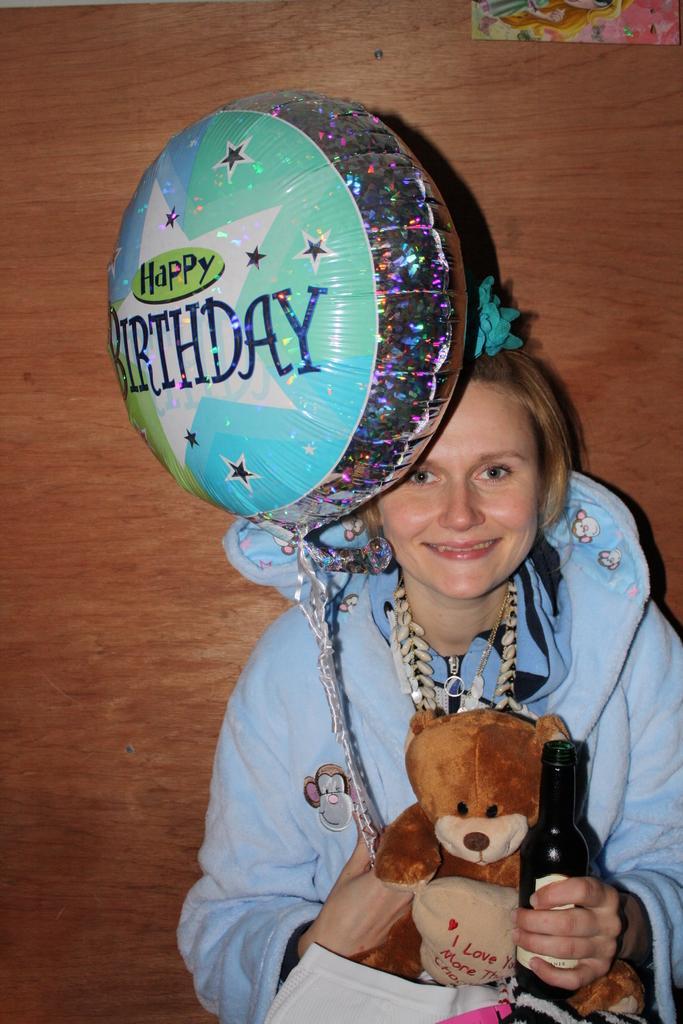In one or two sentences, can you explain what this image depicts? In this picture, woman in blue jacket is holding teddy bear in one of her hand and on the other hand she is holding a beer bottle and she is smiling. In front of her, we see a book. In one of her hand, she is even holding the thread of balloon on which it is written as 'Happy Birthday'. Behind her, there is a wall which is brown in color. 